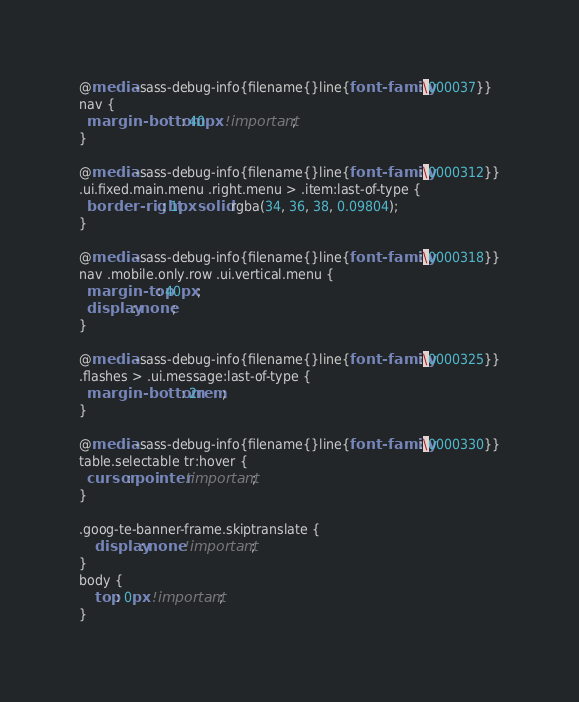<code> <loc_0><loc_0><loc_500><loc_500><_CSS_>@media -sass-debug-info{filename{}line{font-family:\000037}}
nav {
  margin-bottom: 40px !important;
}

@media -sass-debug-info{filename{}line{font-family:\0000312}}
.ui.fixed.main.menu .right.menu > .item:last-of-type {
  border-right: 1px solid rgba(34, 36, 38, 0.09804);
}

@media -sass-debug-info{filename{}line{font-family:\0000318}}
nav .mobile.only.row .ui.vertical.menu {
  margin-top: 40px;
  display: none;
}

@media -sass-debug-info{filename{}line{font-family:\0000325}}
.flashes > .ui.message:last-of-type {
  margin-bottom: 2rem;
}

@media -sass-debug-info{filename{}line{font-family:\0000330}}
table.selectable tr:hover {
  cursor: pointer !important;
}

.goog-te-banner-frame.skiptranslate {
    display: none !important;
} 
body {
    top: 0px !important; 
}</code> 